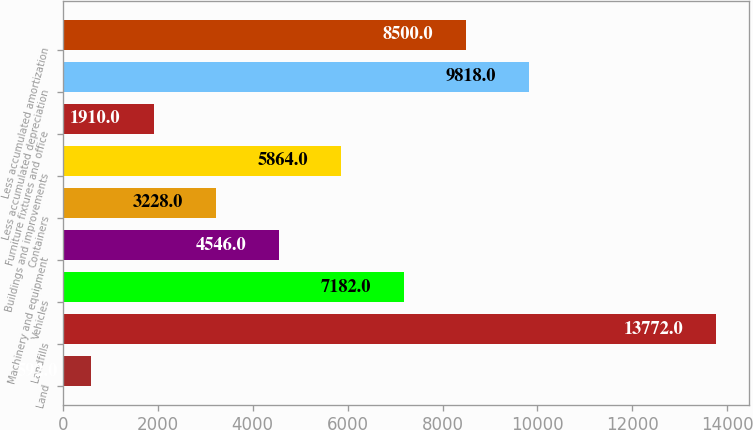Convert chart to OTSL. <chart><loc_0><loc_0><loc_500><loc_500><bar_chart><fcel>Land<fcel>Landfills<fcel>Vehicles<fcel>Machinery and equipment<fcel>Containers<fcel>Buildings and improvements<fcel>Furniture fixtures and office<fcel>Less accumulated depreciation<fcel>Less accumulated amortization<nl><fcel>592<fcel>13772<fcel>7182<fcel>4546<fcel>3228<fcel>5864<fcel>1910<fcel>9818<fcel>8500<nl></chart> 